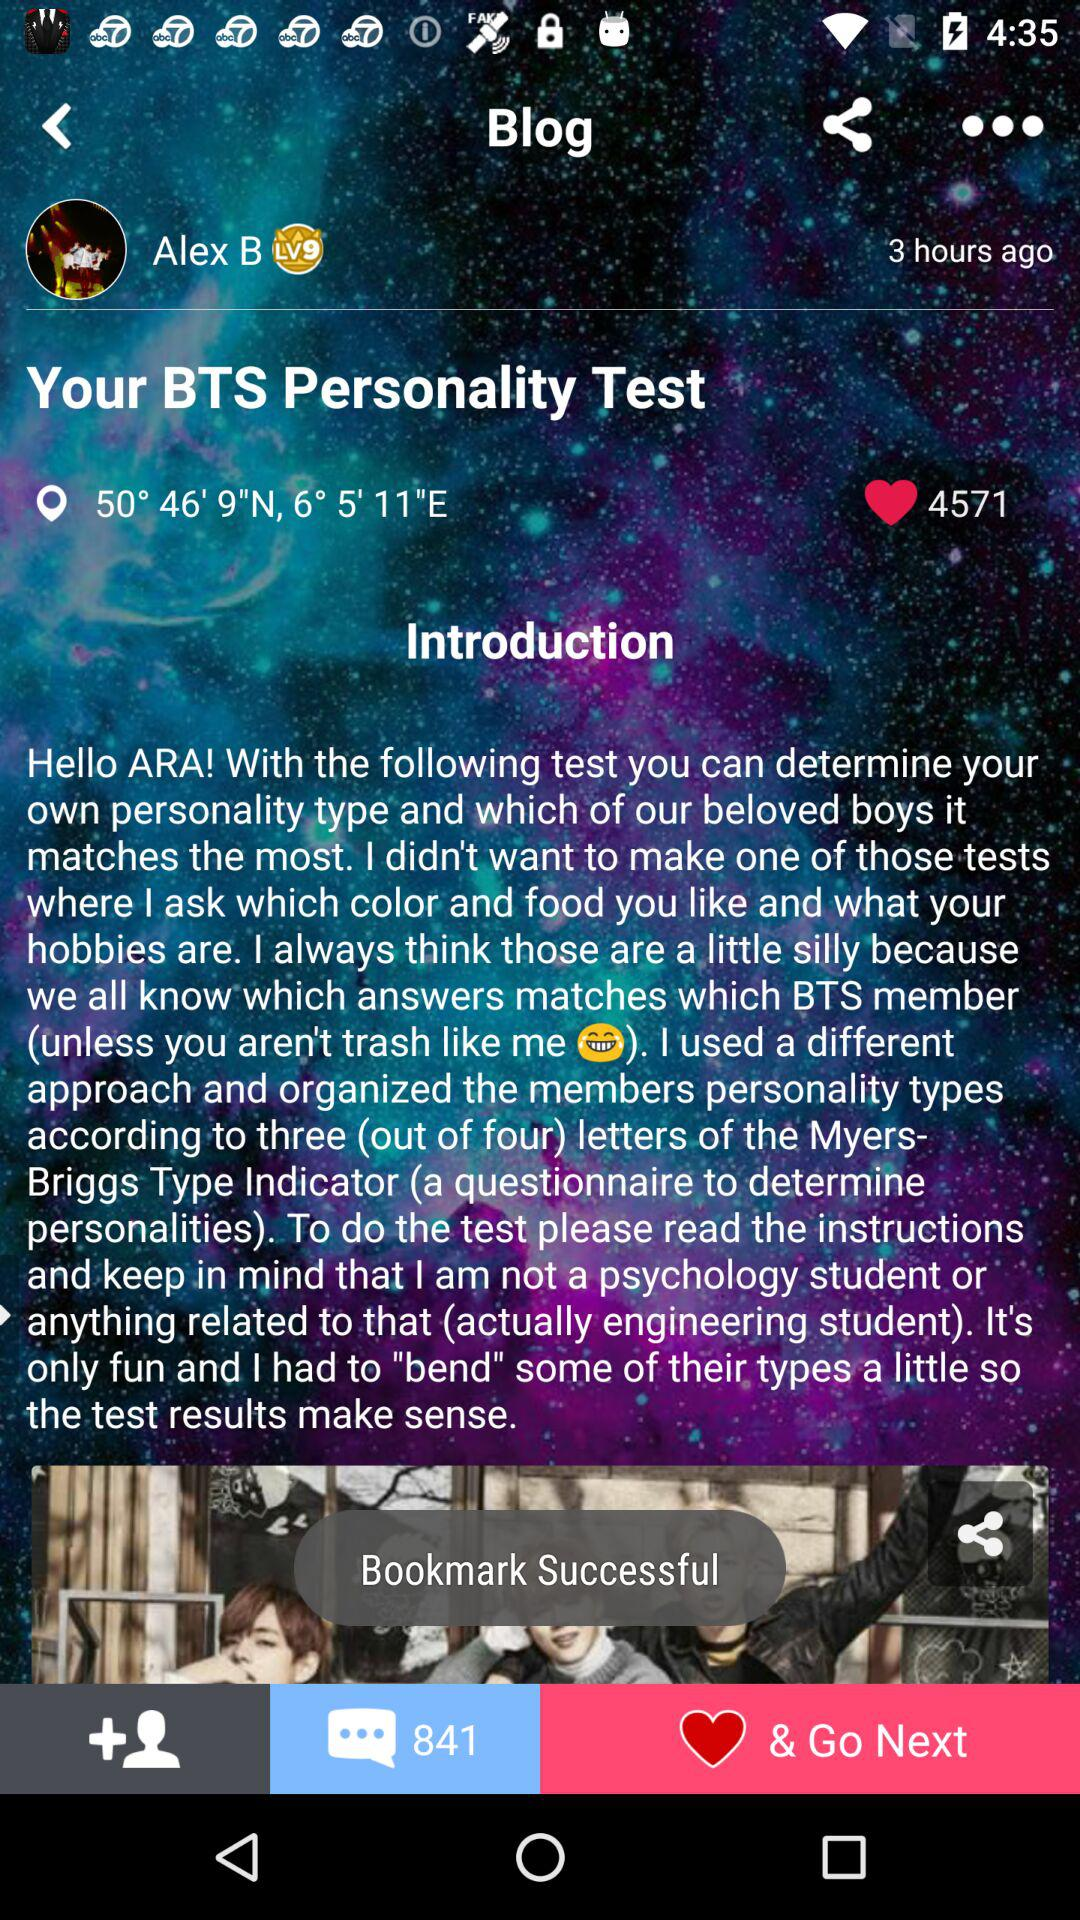When was the blog updated? The blog was updated 3 hours ago. 